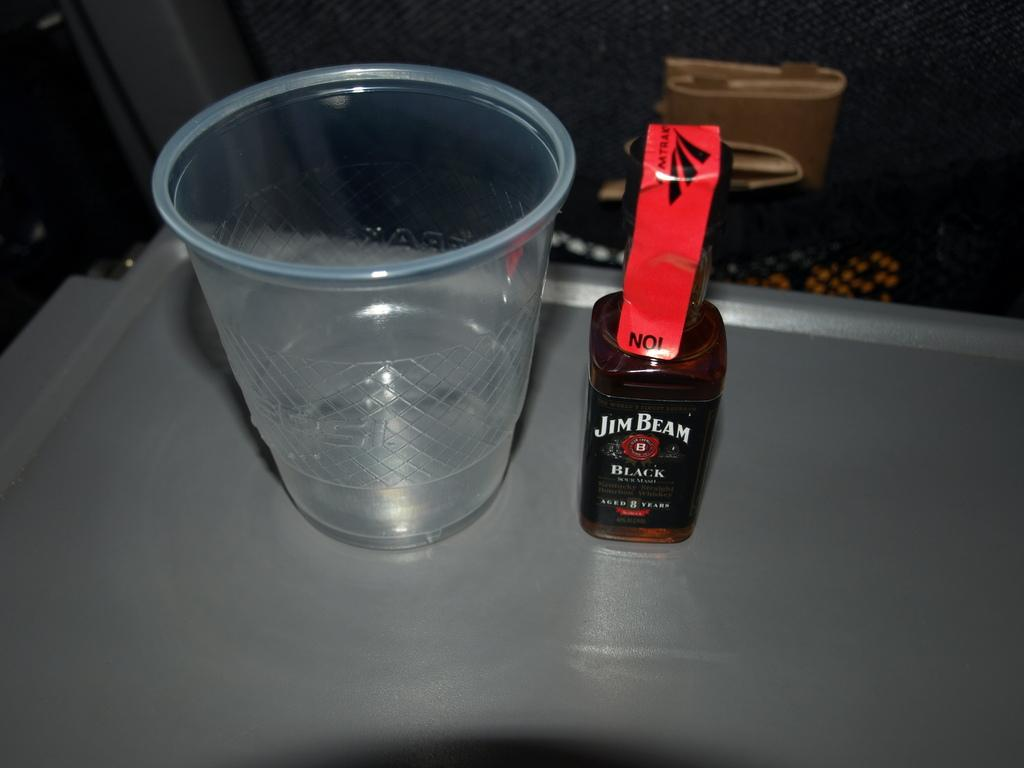What object is located in the center of the image? There is a glass in the center of the image. What is positioned next to the glass? There is a bottle beside the glass. What color is the surface beneath the glass and bottle? The surface beneath the glass and bottle is silver-colored. How many books are stacked on top of the glass in the image? There are no books present in the image. 